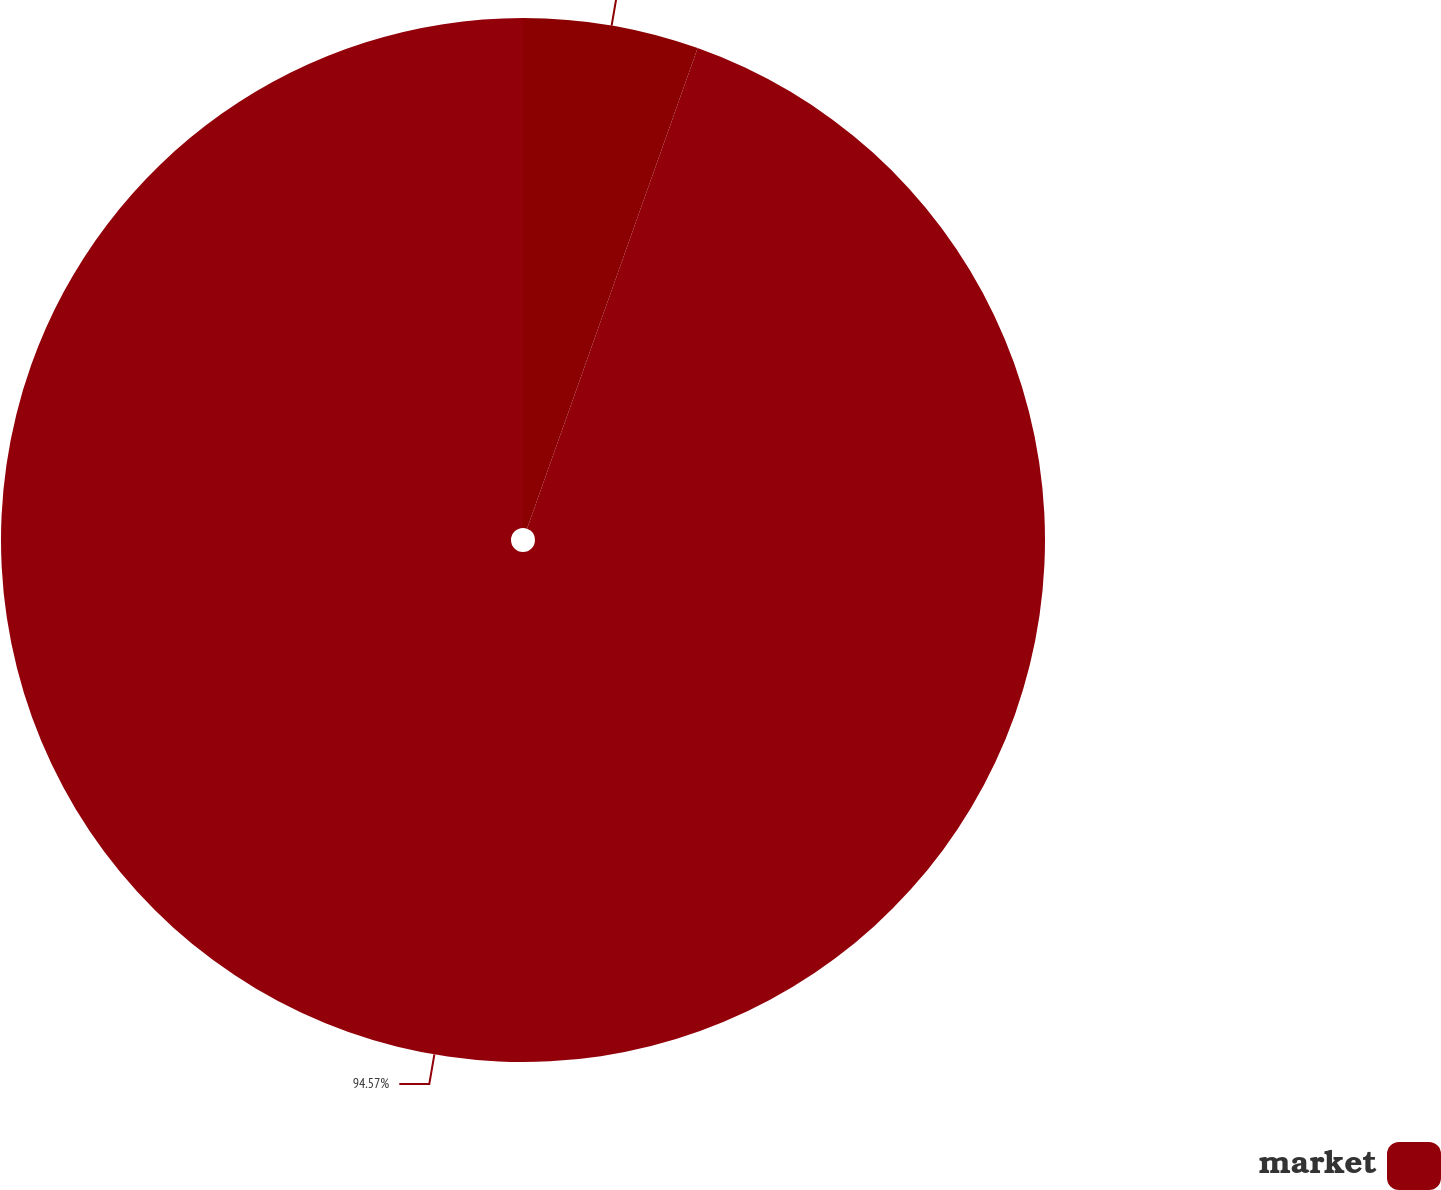Convert chart to OTSL. <chart><loc_0><loc_0><loc_500><loc_500><pie_chart><ecel><fcel>market<nl><fcel>5.43%<fcel>94.57%<nl></chart> 